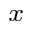<formula> <loc_0><loc_0><loc_500><loc_500>_ { x }</formula> 